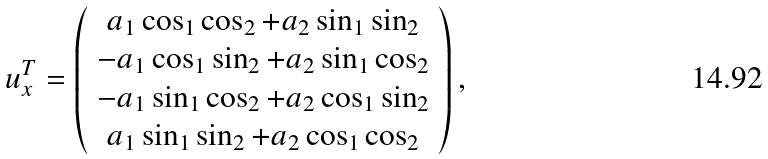Convert formula to latex. <formula><loc_0><loc_0><loc_500><loc_500>u _ { x } ^ { T } = \left ( \begin{array} { c c c c } a _ { 1 } \cos _ { 1 } \cos _ { 2 } + a _ { 2 } \sin _ { 1 } \sin _ { 2 } \\ - a _ { 1 } \cos _ { 1 } \sin _ { 2 } + a _ { 2 } \sin _ { 1 } \cos _ { 2 } \\ - a _ { 1 } \sin _ { 1 } \cos _ { 2 } + a _ { 2 } \cos _ { 1 } \sin _ { 2 } \\ a _ { 1 } \sin _ { 1 } \sin _ { 2 } + a _ { 2 } \cos _ { 1 } \cos _ { 2 } \\ \end{array} \right ) ,</formula> 